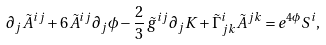Convert formula to latex. <formula><loc_0><loc_0><loc_500><loc_500>\partial _ { j } \tilde { A } ^ { i j } + 6 \tilde { A } ^ { i j } \partial _ { j } \phi - \frac { 2 } { 3 } \, \tilde { g } ^ { i j } \partial _ { j } K + \tilde { \Gamma } ^ { i } _ { j k } \tilde { A } ^ { j k } = e ^ { 4 \phi } S ^ { i } ,</formula> 